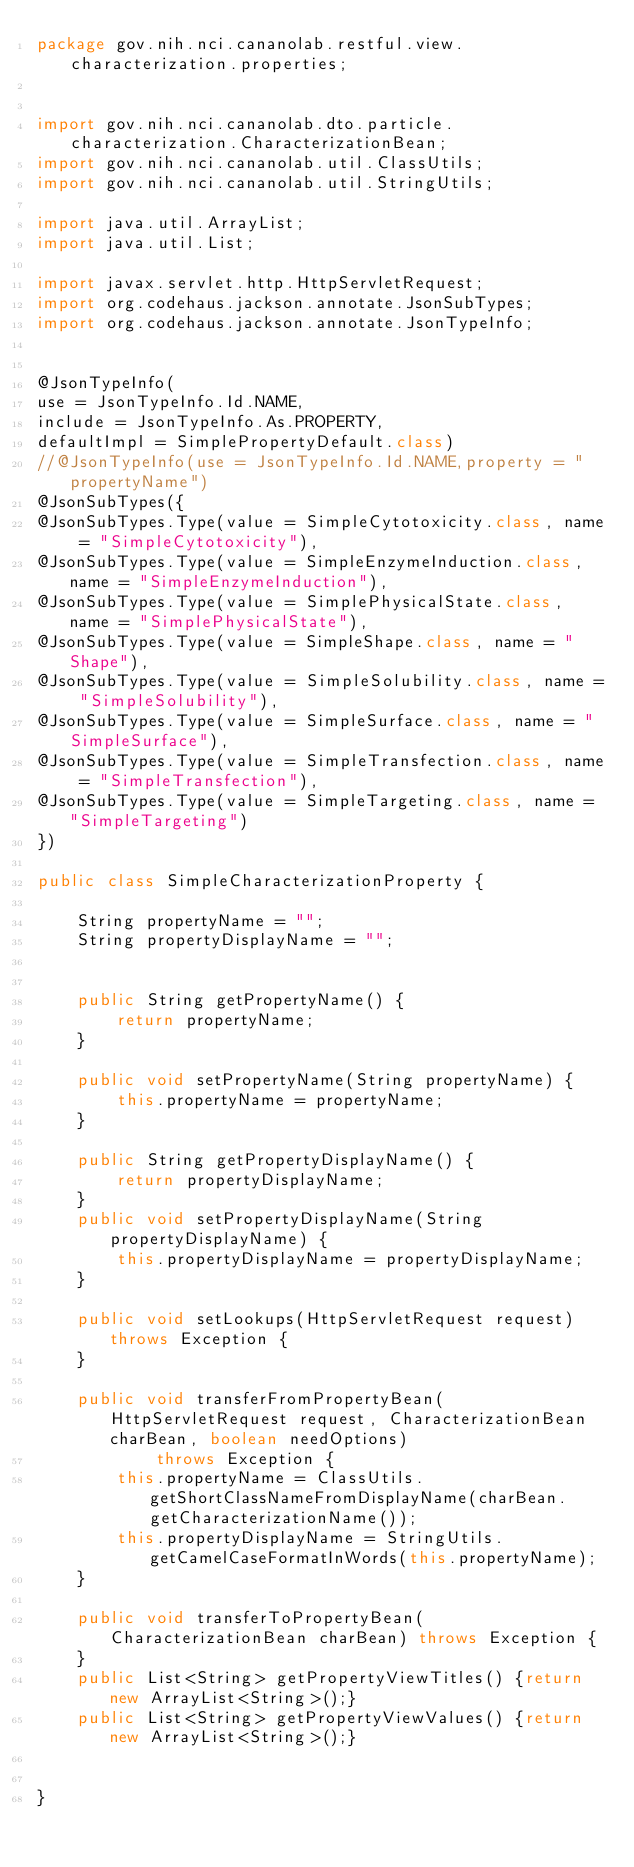<code> <loc_0><loc_0><loc_500><loc_500><_Java_>package gov.nih.nci.cananolab.restful.view.characterization.properties;


import gov.nih.nci.cananolab.dto.particle.characterization.CharacterizationBean;
import gov.nih.nci.cananolab.util.ClassUtils;
import gov.nih.nci.cananolab.util.StringUtils;

import java.util.ArrayList;
import java.util.List;

import javax.servlet.http.HttpServletRequest;
import org.codehaus.jackson.annotate.JsonSubTypes;
import org.codehaus.jackson.annotate.JsonTypeInfo;


@JsonTypeInfo(
use = JsonTypeInfo.Id.NAME,
include = JsonTypeInfo.As.PROPERTY,
defaultImpl = SimplePropertyDefault.class)
//@JsonTypeInfo(use = JsonTypeInfo.Id.NAME,property = "propertyName")
@JsonSubTypes({
@JsonSubTypes.Type(value = SimpleCytotoxicity.class, name = "SimpleCytotoxicity"),
@JsonSubTypes.Type(value = SimpleEnzymeInduction.class, name = "SimpleEnzymeInduction"),
@JsonSubTypes.Type(value = SimplePhysicalState.class, name = "SimplePhysicalState"),
@JsonSubTypes.Type(value = SimpleShape.class, name = "Shape"),
@JsonSubTypes.Type(value = SimpleSolubility.class, name = "SimpleSolubility"),
@JsonSubTypes.Type(value = SimpleSurface.class, name = "SimpleSurface"),
@JsonSubTypes.Type(value = SimpleTransfection.class, name = "SimpleTransfection"),
@JsonSubTypes.Type(value = SimpleTargeting.class, name = "SimpleTargeting")
})

public class SimpleCharacterizationProperty {

	String propertyName = "";
	String propertyDisplayName = "";


	public String getPropertyName() {
		return propertyName;
	}
	
	public void setPropertyName(String propertyName) {
		this.propertyName = propertyName;
	}
	
	public String getPropertyDisplayName() {
		return propertyDisplayName;
	}
	public void setPropertyDisplayName(String propertyDisplayName) {
		this.propertyDisplayName = propertyDisplayName;
	}
	
	public void setLookups(HttpServletRequest request) throws Exception {
    }
	
	public void transferFromPropertyBean(HttpServletRequest request, CharacterizationBean charBean, boolean needOptions) 
			throws Exception {
		this.propertyName = ClassUtils.getShortClassNameFromDisplayName(charBean.getCharacterizationName());
		this.propertyDisplayName = StringUtils.getCamelCaseFormatInWords(this.propertyName);
	}
	
	public void transferToPropertyBean(CharacterizationBean charBean) throws Exception {
    }
	public List<String> getPropertyViewTitles() {return new ArrayList<String>();}
	public List<String> getPropertyViewValues() {return new ArrayList<String>();}


}
</code> 